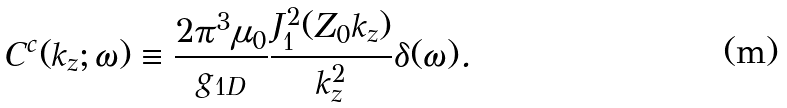<formula> <loc_0><loc_0><loc_500><loc_500>C ^ { c } ( k _ { z } ; \omega ) \equiv \frac { 2 \pi ^ { 3 } \mu _ { 0 } } { g _ { 1 D } } \frac { J _ { 1 } ^ { 2 } ( Z _ { 0 } k _ { z } ) } { k _ { z } ^ { 2 } } \delta ( \omega ) .</formula> 